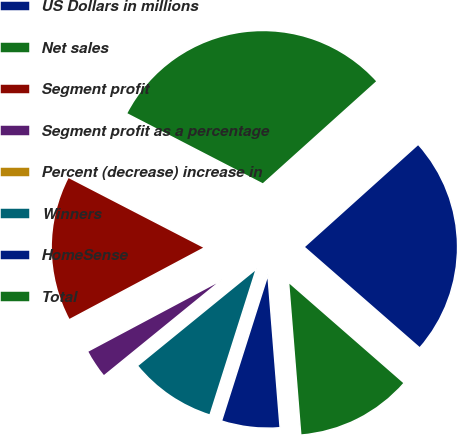<chart> <loc_0><loc_0><loc_500><loc_500><pie_chart><fcel>US Dollars in millions<fcel>Net sales<fcel>Segment profit<fcel>Segment profit as a percentage<fcel>Percent (decrease) increase in<fcel>Winners<fcel>HomeSense<fcel>Total<nl><fcel>23.08%<fcel>30.75%<fcel>15.38%<fcel>3.08%<fcel>0.01%<fcel>9.23%<fcel>6.16%<fcel>12.31%<nl></chart> 